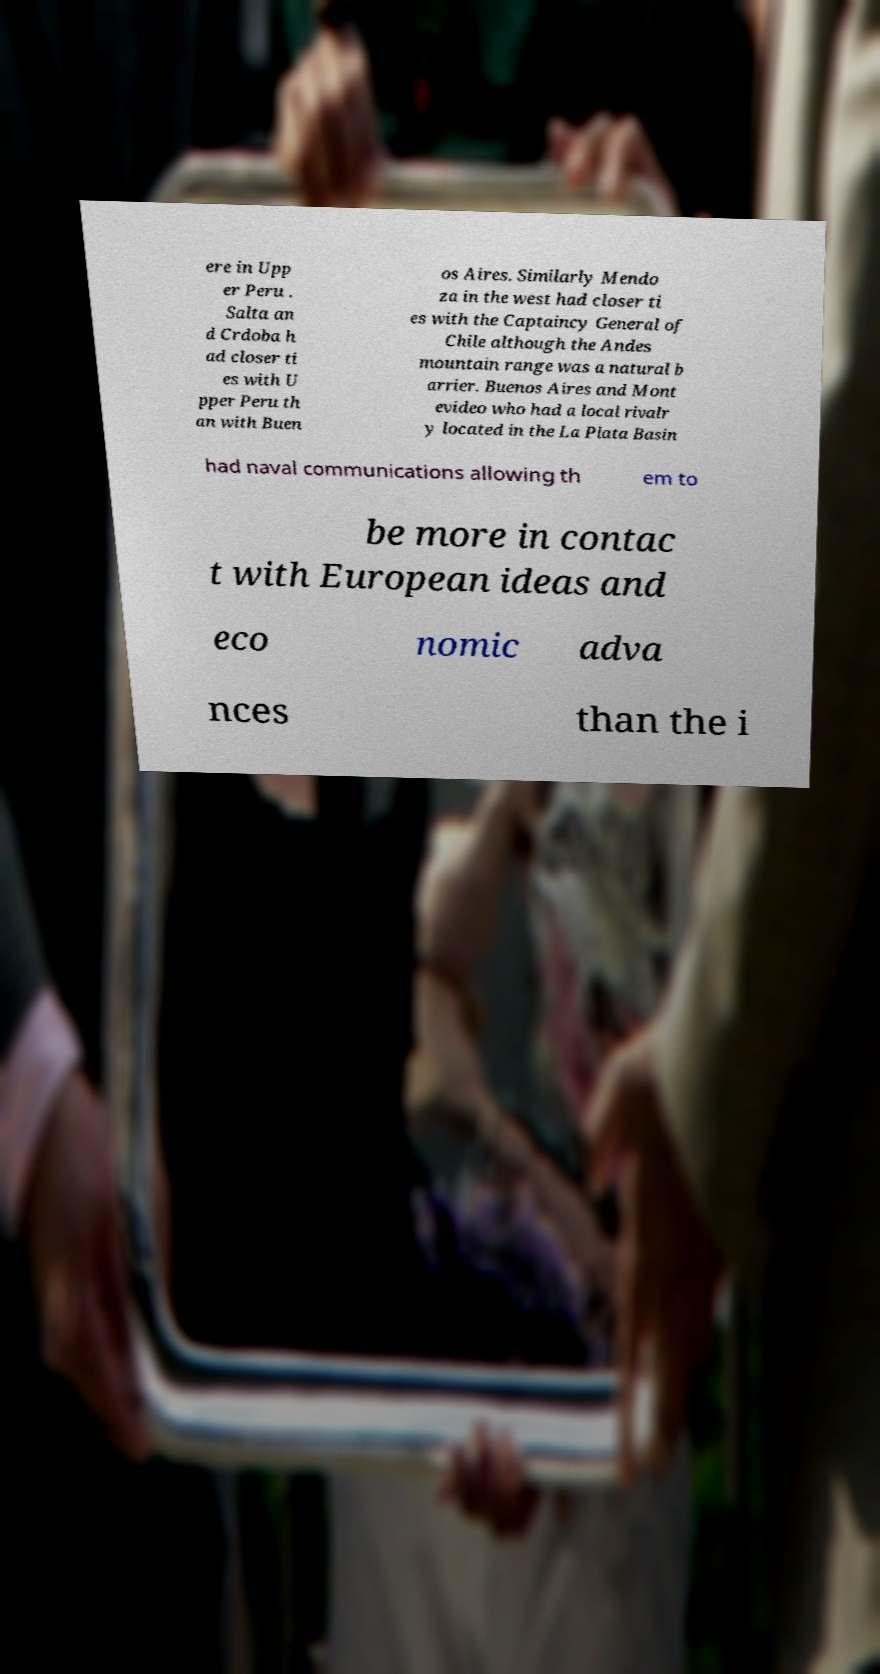Please read and relay the text visible in this image. What does it say? ere in Upp er Peru . Salta an d Crdoba h ad closer ti es with U pper Peru th an with Buen os Aires. Similarly Mendo za in the west had closer ti es with the Captaincy General of Chile although the Andes mountain range was a natural b arrier. Buenos Aires and Mont evideo who had a local rivalr y located in the La Plata Basin had naval communications allowing th em to be more in contac t with European ideas and eco nomic adva nces than the i 